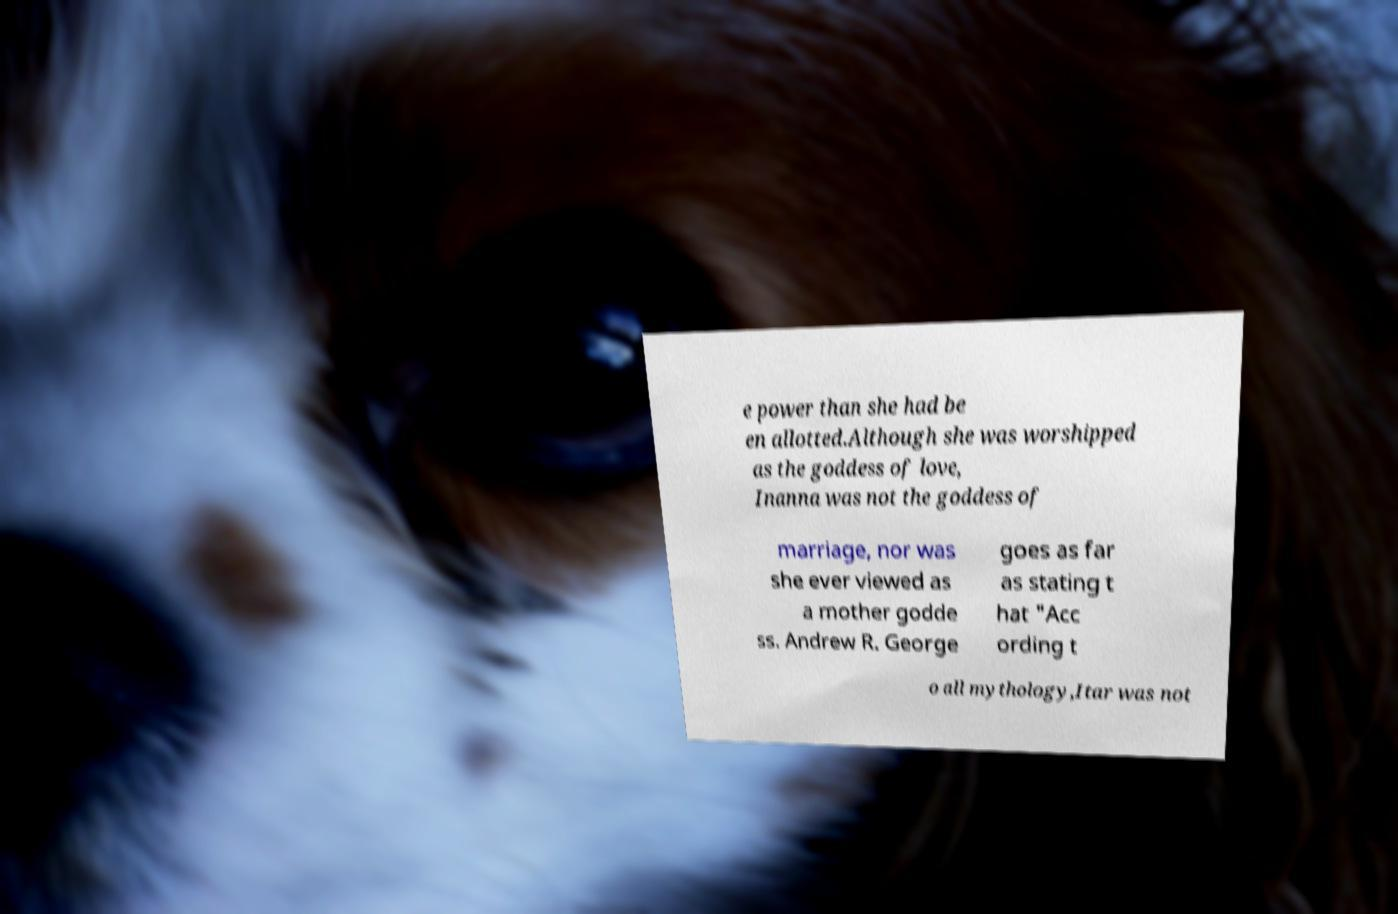I need the written content from this picture converted into text. Can you do that? e power than she had be en allotted.Although she was worshipped as the goddess of love, Inanna was not the goddess of marriage, nor was she ever viewed as a mother godde ss. Andrew R. George goes as far as stating t hat "Acc ording t o all mythology,Itar was not 